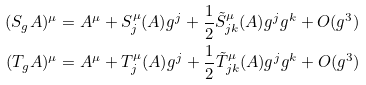<formula> <loc_0><loc_0><loc_500><loc_500>( S _ { g } A ) ^ { \mu } & = A ^ { \mu } + S ^ { \mu } _ { j } ( A ) g ^ { j } + \frac { 1 } { 2 } \tilde { S } ^ { \mu } _ { j k } ( A ) g ^ { j } g ^ { k } + O ( g ^ { 3 } ) \\ ( T _ { g } A ) ^ { \mu } & = A ^ { \mu } + T ^ { \mu } _ { j } ( A ) g ^ { j } + \frac { 1 } { 2 } \tilde { T } ^ { \mu } _ { j k } ( A ) g ^ { j } g ^ { k } + O ( g ^ { 3 } )</formula> 